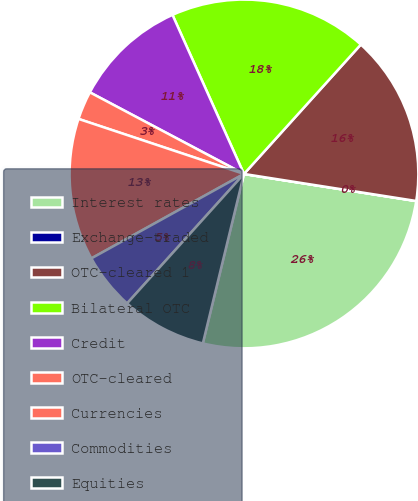Convert chart. <chart><loc_0><loc_0><loc_500><loc_500><pie_chart><fcel>Interest rates<fcel>Exchange-traded<fcel>OTC-cleared 1<fcel>Bilateral OTC<fcel>Credit<fcel>OTC-cleared<fcel>Currencies<fcel>Commodities<fcel>Equities<nl><fcel>26.31%<fcel>0.01%<fcel>15.79%<fcel>18.42%<fcel>10.53%<fcel>2.64%<fcel>13.16%<fcel>5.27%<fcel>7.9%<nl></chart> 